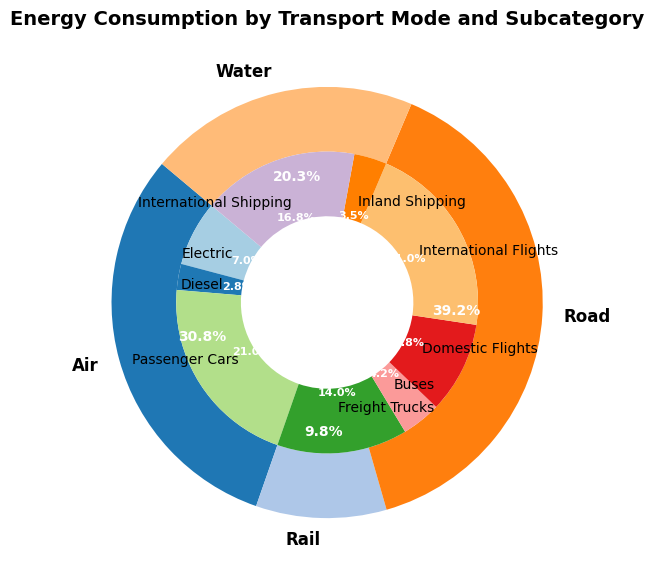How much total energy consumption is attributed to the rail mode and its subcategories? First, find the energy consumption for Electric Rail (50,000 TJ) and Diesel Rail (20,000 TJ). Add these values together: 50,000 + 20,000 = 70,000 TJ.
Answer: 70,000 TJ Which transport mode has the highest energy consumption in the figure? Compare the total energy consumption of each transport mode. The pie chart shows Air with the highest percentage. Summing up its subcategories confirms this: Domestic Flights (70,000 TJ) and International Flights (150,000 TJ) give a total of 220,000 TJ.
Answer: Air Does Road consume more energy than Water? Sum the energy consumption for Road subcategories: Passenger Cars (150,000 TJ), Freight Trucks (100,000 TJ), and Buses (30,000 TJ) to get 280,000 TJ. Sum the energy consumption for Water subcategories: Inland Shipping (25,000 TJ) and International Shipping (120,000 TJ) to get 145,000 TJ. Compare 280,000 TJ to 145,000 TJ, confirming that Road consumes more energy.
Answer: Yes What is the percentage of total energy consumption used by Diesel in Rail compared to the entire dataset? Calculate the total energy consumption of all subcategories: 50000 + 20000 + 150000 + 100000 + 30000 + 70000 + 150000 + 25000 + 120000 = 715000 TJ. Diesel in Rail is 20,000 TJ. Divide 20,000 by 715,000 and multiply by 100 to get (20,000 / 715,000) * 100 ≈ 2.8%.
Answer: 2.8% Are Passenger Cars consuming more energy than Domestic Flights? Compare the energy consumption of Passenger Cars (150,000 TJ) with Domestic Flights (70,000 TJ). Passenger Cars consume more energy.
Answer: Yes Which subcategory has the lowest energy consumption in the figure? Identify and compare the energy consumption of each subcategory. Inland Shipping has the lowest energy consumption at 25,000 TJ.
Answer: Inland Shipping What is the combined percentage of energy consumption from International Flights and International Shipping? Calculate the total energy consumption first: 715,000 TJ. Add the energy consumption for International Flights (150,000 TJ) and International Shipping (120,000 TJ): 150,000 + 120,000 = 270,000 TJ. Divide 270,000 by 715,000 and multiply by 100 to get (270,000 / 715,000) * 100 ≈ 37.8%.
Answer: 37.8% Which transport mode is represented by the orange section of the outer ring? Examine the colors used in the pie chart. The orange section of the inner ring represents Water with 14.5% and the outer ring visible in two segments without specific color shade, therefore should be verified showing Inland Shipping and International Shipping dipped by 3.5% and 3.2%.
Answer: Water What color represents the Passenger Cars subcategory? Observe the different sections of the inner ring and their respective colors. The Passenger Cars subcategory is represented by blue.
Answer: Blue What's the total energy consumption difference between Road and Air categories? Calculate the total energy consumption for Road (280,000 TJ) and Air (220,000 TJ). Subtract the Air value from the Road value: 280,000 - 220,000 = 60,000 TJ.
Answer: 60,000 TJ 